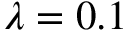<formula> <loc_0><loc_0><loc_500><loc_500>\lambda = 0 . 1</formula> 